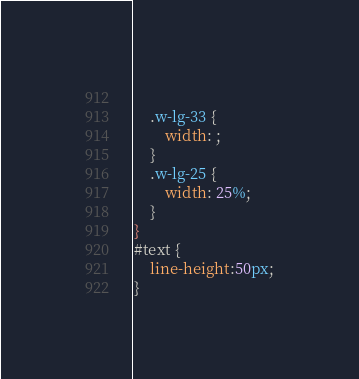<code> <loc_0><loc_0><loc_500><loc_500><_CSS_>    
    .w-lg-33 {
        width: ;
    }
    .w-lg-25 {
        width: 25%;
    }
}
#text {
    line-height:50px;
}



</code> 